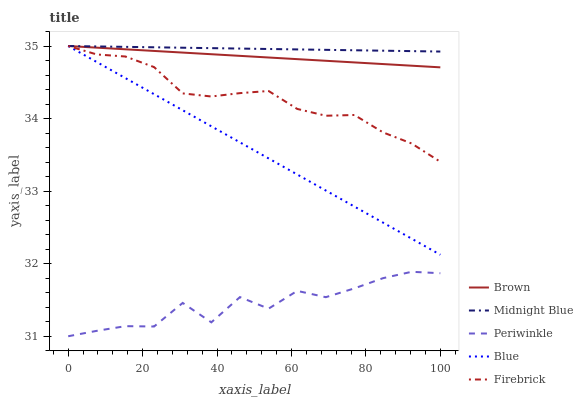Does Periwinkle have the minimum area under the curve?
Answer yes or no. Yes. Does Midnight Blue have the maximum area under the curve?
Answer yes or no. Yes. Does Brown have the minimum area under the curve?
Answer yes or no. No. Does Brown have the maximum area under the curve?
Answer yes or no. No. Is Midnight Blue the smoothest?
Answer yes or no. Yes. Is Periwinkle the roughest?
Answer yes or no. Yes. Is Brown the smoothest?
Answer yes or no. No. Is Brown the roughest?
Answer yes or no. No. Does Periwinkle have the lowest value?
Answer yes or no. Yes. Does Brown have the lowest value?
Answer yes or no. No. Does Midnight Blue have the highest value?
Answer yes or no. Yes. Does Periwinkle have the highest value?
Answer yes or no. No. Is Periwinkle less than Brown?
Answer yes or no. Yes. Is Brown greater than Periwinkle?
Answer yes or no. Yes. Does Midnight Blue intersect Blue?
Answer yes or no. Yes. Is Midnight Blue less than Blue?
Answer yes or no. No. Is Midnight Blue greater than Blue?
Answer yes or no. No. Does Periwinkle intersect Brown?
Answer yes or no. No. 